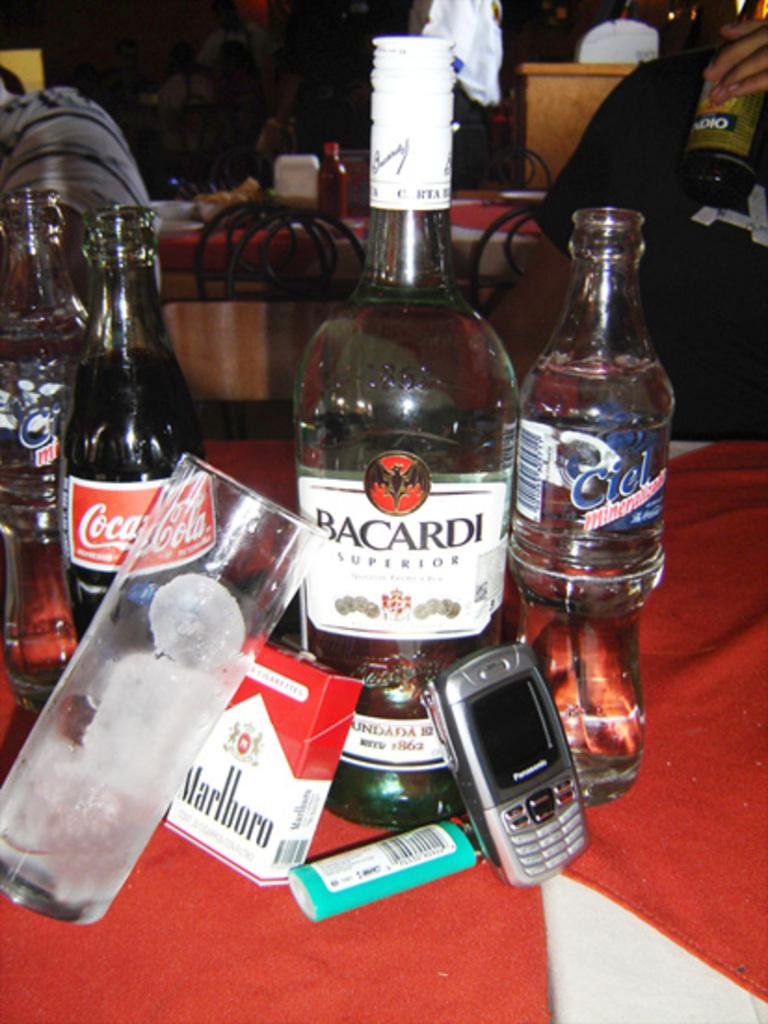<image>
Create a compact narrative representing the image presented. A bottle of Bacardi Superior sits on a table with other bottles and objects. 